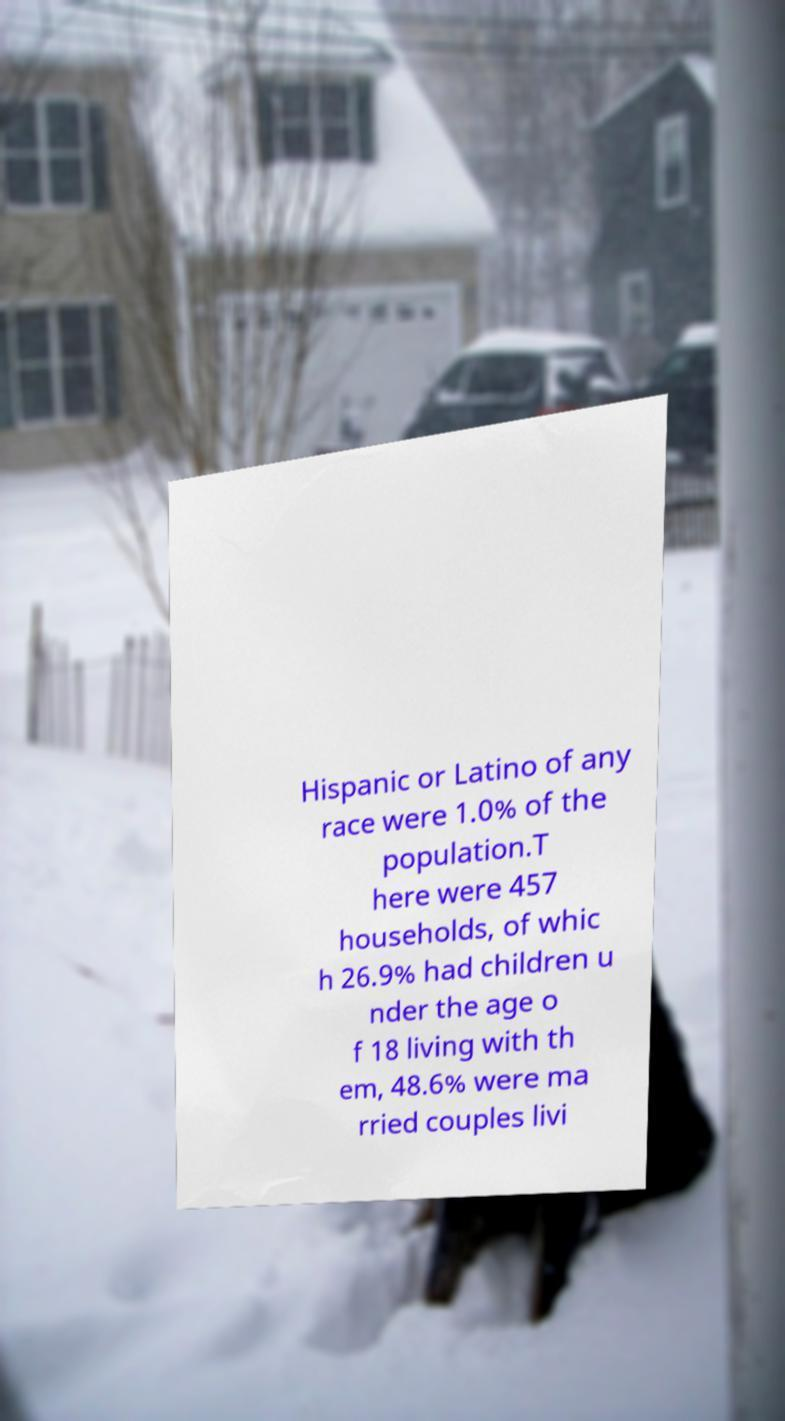There's text embedded in this image that I need extracted. Can you transcribe it verbatim? Hispanic or Latino of any race were 1.0% of the population.T here were 457 households, of whic h 26.9% had children u nder the age o f 18 living with th em, 48.6% were ma rried couples livi 